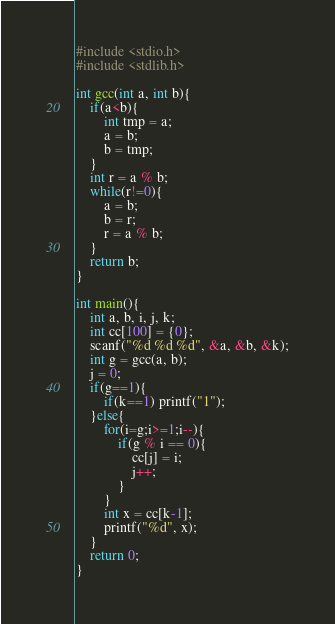<code> <loc_0><loc_0><loc_500><loc_500><_C_>#include <stdio.h>
#include <stdlib.h>

int gcc(int a, int b){
    if(a<b){
        int tmp = a;
        a = b;
        b = tmp;
    }
    int r = a % b;
    while(r!=0){
        a = b;
        b = r;
        r = a % b;
    }
    return b;
}

int main(){
    int a, b, i, j, k;
    int cc[100] = {0};
    scanf("%d %d %d", &a, &b, &k);
    int g = gcc(a, b);
    j = 0;
    if(g==1){
        if(k==1) printf("1");
    }else{
        for(i=g;i>=1;i--){
            if(g % i == 0){
                cc[j] = i;
                j++;
            }
        }
        int x = cc[k-1];
        printf("%d", x);
    }
    return 0;
}</code> 